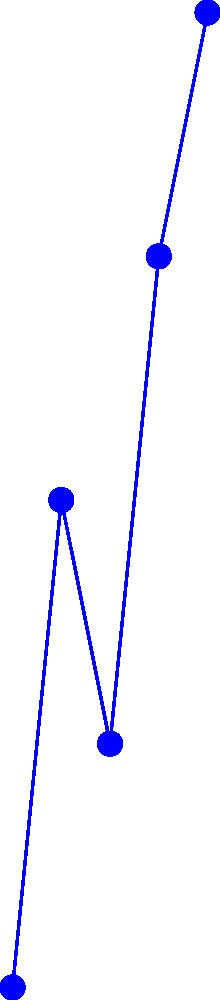Analyze the cash flow statement represented in the graph above. Calculate the net cash flow for Year 3 and determine whether the company's overall cash position improved or deteriorated compared to Year 2. To solve this problem, we need to follow these steps:

1. Identify the cash flows for each activity in Year 3:
   Operating: $65,000
   Investing: $-20,000
   Financing: $-25,000

2. Calculate the net cash flow for Year 3:
   Net Cash Flow = Operating + Investing + Financing
   Net Cash Flow = $65,000 + ($-20,000) + ($-25,000) = $20,000

3. Compare Year 3's net cash flow to Year 2's:
   Year 2 net cash flow = $55,000 + ($-35,000) + ($-5,000) = $15,000
   Year 3 net cash flow = $20,000

4. Determine if the cash position improved or deteriorated:
   Since Year 3's net cash flow ($20,000) is greater than Year 2's ($15,000), the company's overall cash position improved.
Answer: Net cash flow for Year 3: $20,000; Cash position improved. 